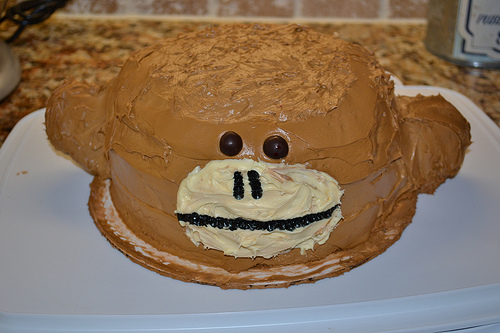<image>
Is the cake on the monkey face? No. The cake is not positioned on the monkey face. They may be near each other, but the cake is not supported by or resting on top of the monkey face. 